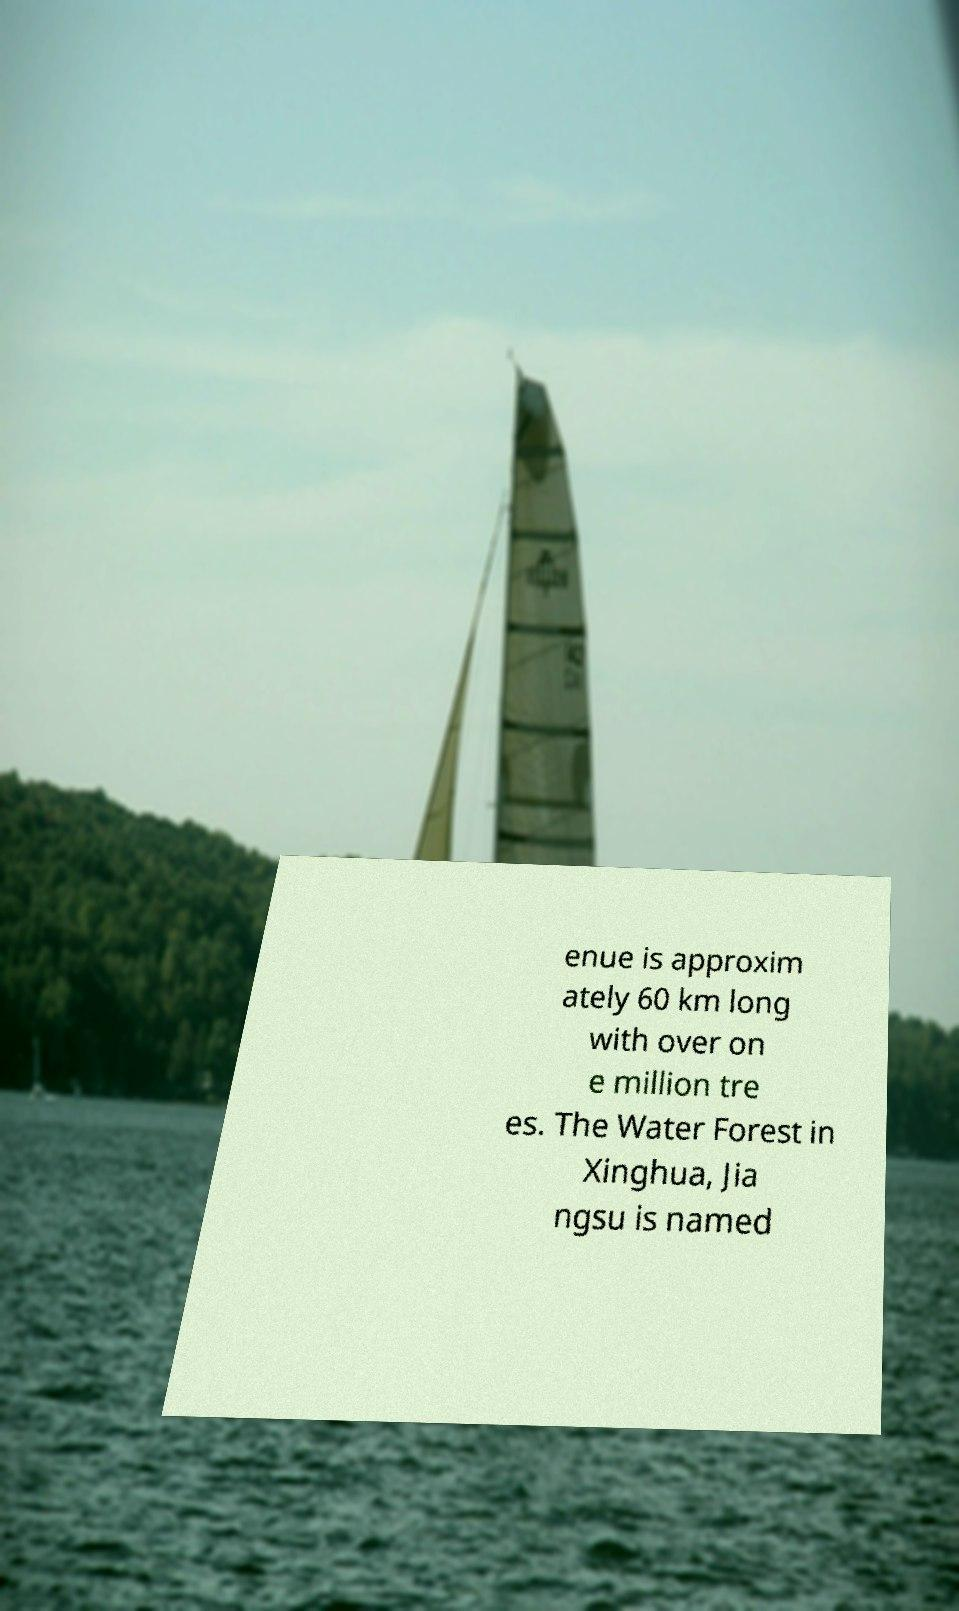Could you extract and type out the text from this image? enue is approxim ately 60 km long with over on e million tre es. The Water Forest in Xinghua, Jia ngsu is named 